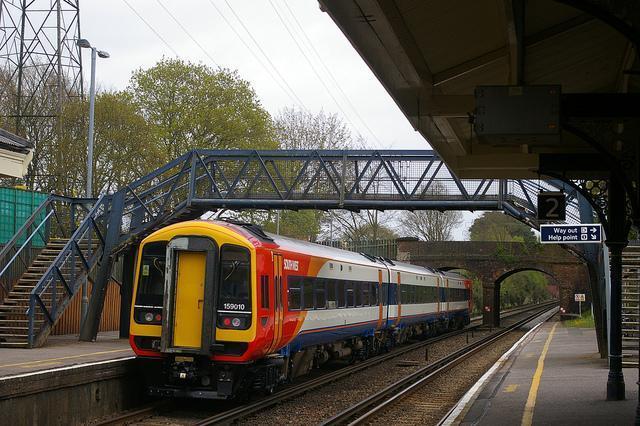How many people are sitting on the floor?
Give a very brief answer. 0. 